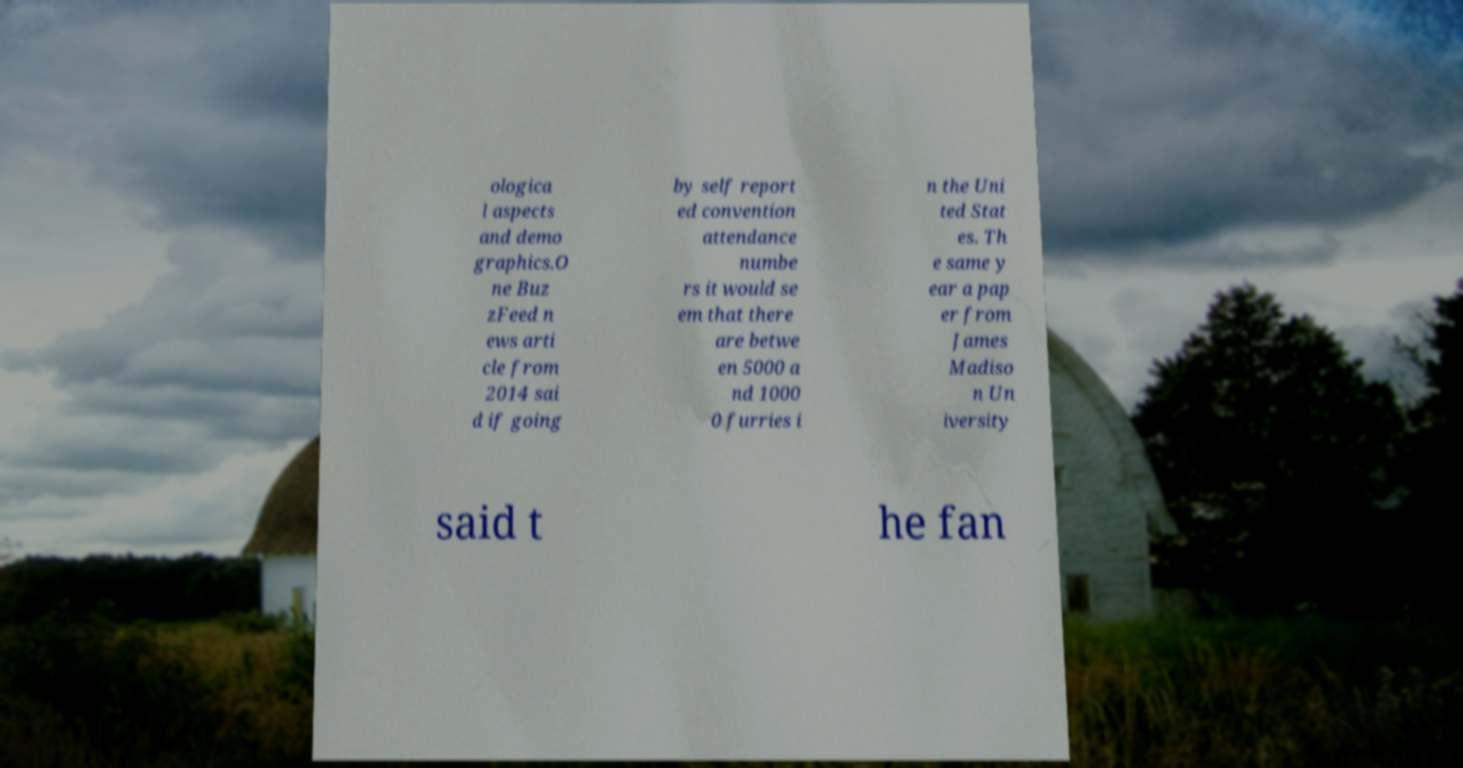Please read and relay the text visible in this image. What does it say? ologica l aspects and demo graphics.O ne Buz zFeed n ews arti cle from 2014 sai d if going by self report ed convention attendance numbe rs it would se em that there are betwe en 5000 a nd 1000 0 furries i n the Uni ted Stat es. Th e same y ear a pap er from James Madiso n Un iversity said t he fan 